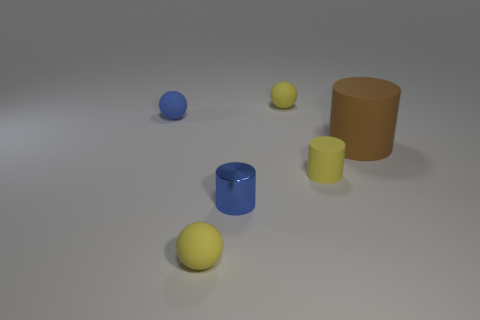Subtract all yellow spheres. How many spheres are left? 1 Add 2 red spheres. How many objects exist? 8 Subtract 2 cylinders. How many cylinders are left? 1 Add 2 small yellow balls. How many small yellow balls are left? 4 Add 5 brown matte objects. How many brown matte objects exist? 6 Subtract all blue cylinders. How many cylinders are left? 2 Subtract 0 gray spheres. How many objects are left? 6 Subtract all gray spheres. Subtract all cyan cylinders. How many spheres are left? 3 Subtract all green cylinders. How many yellow spheres are left? 2 Subtract all metal cylinders. Subtract all red shiny balls. How many objects are left? 5 